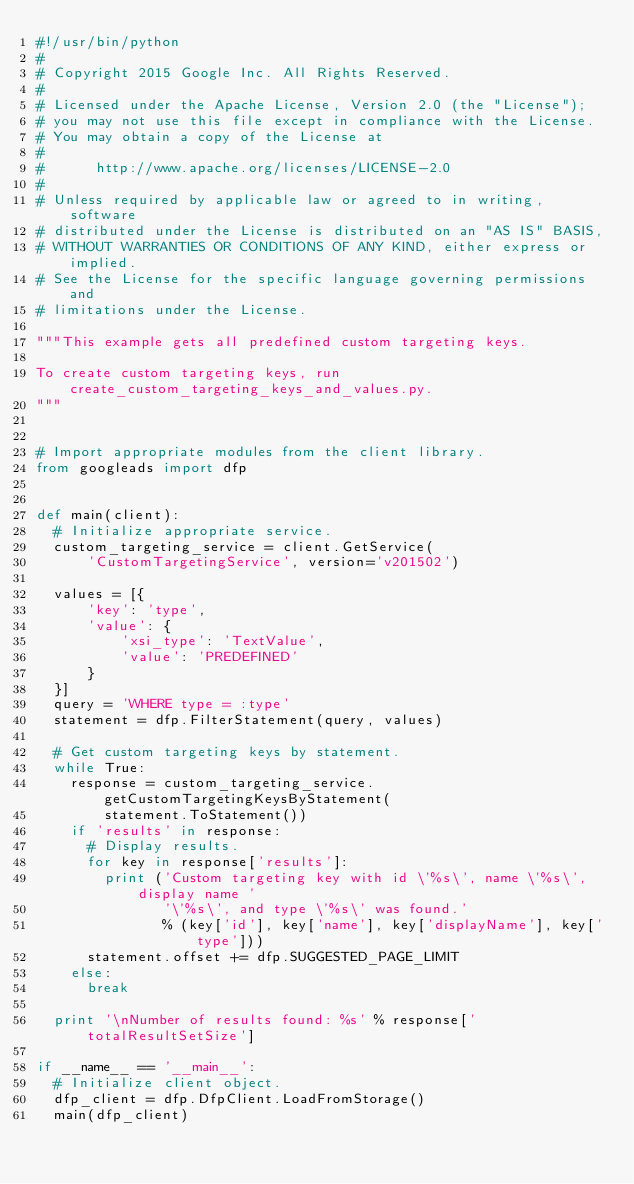<code> <loc_0><loc_0><loc_500><loc_500><_Python_>#!/usr/bin/python
#
# Copyright 2015 Google Inc. All Rights Reserved.
#
# Licensed under the Apache License, Version 2.0 (the "License");
# you may not use this file except in compliance with the License.
# You may obtain a copy of the License at
#
#      http://www.apache.org/licenses/LICENSE-2.0
#
# Unless required by applicable law or agreed to in writing, software
# distributed under the License is distributed on an "AS IS" BASIS,
# WITHOUT WARRANTIES OR CONDITIONS OF ANY KIND, either express or implied.
# See the License for the specific language governing permissions and
# limitations under the License.

"""This example gets all predefined custom targeting keys.

To create custom targeting keys, run create_custom_targeting_keys_and_values.py.
"""


# Import appropriate modules from the client library.
from googleads import dfp


def main(client):
  # Initialize appropriate service.
  custom_targeting_service = client.GetService(
      'CustomTargetingService', version='v201502')

  values = [{
      'key': 'type',
      'value': {
          'xsi_type': 'TextValue',
          'value': 'PREDEFINED'
      }
  }]
  query = 'WHERE type = :type'
  statement = dfp.FilterStatement(query, values)

  # Get custom targeting keys by statement.
  while True:
    response = custom_targeting_service.getCustomTargetingKeysByStatement(
        statement.ToStatement())
    if 'results' in response:
      # Display results.
      for key in response['results']:
        print ('Custom targeting key with id \'%s\', name \'%s\', display name '
               '\'%s\', and type \'%s\' was found.'
               % (key['id'], key['name'], key['displayName'], key['type']))
      statement.offset += dfp.SUGGESTED_PAGE_LIMIT
    else:
      break

  print '\nNumber of results found: %s' % response['totalResultSetSize']

if __name__ == '__main__':
  # Initialize client object.
  dfp_client = dfp.DfpClient.LoadFromStorage()
  main(dfp_client)
</code> 